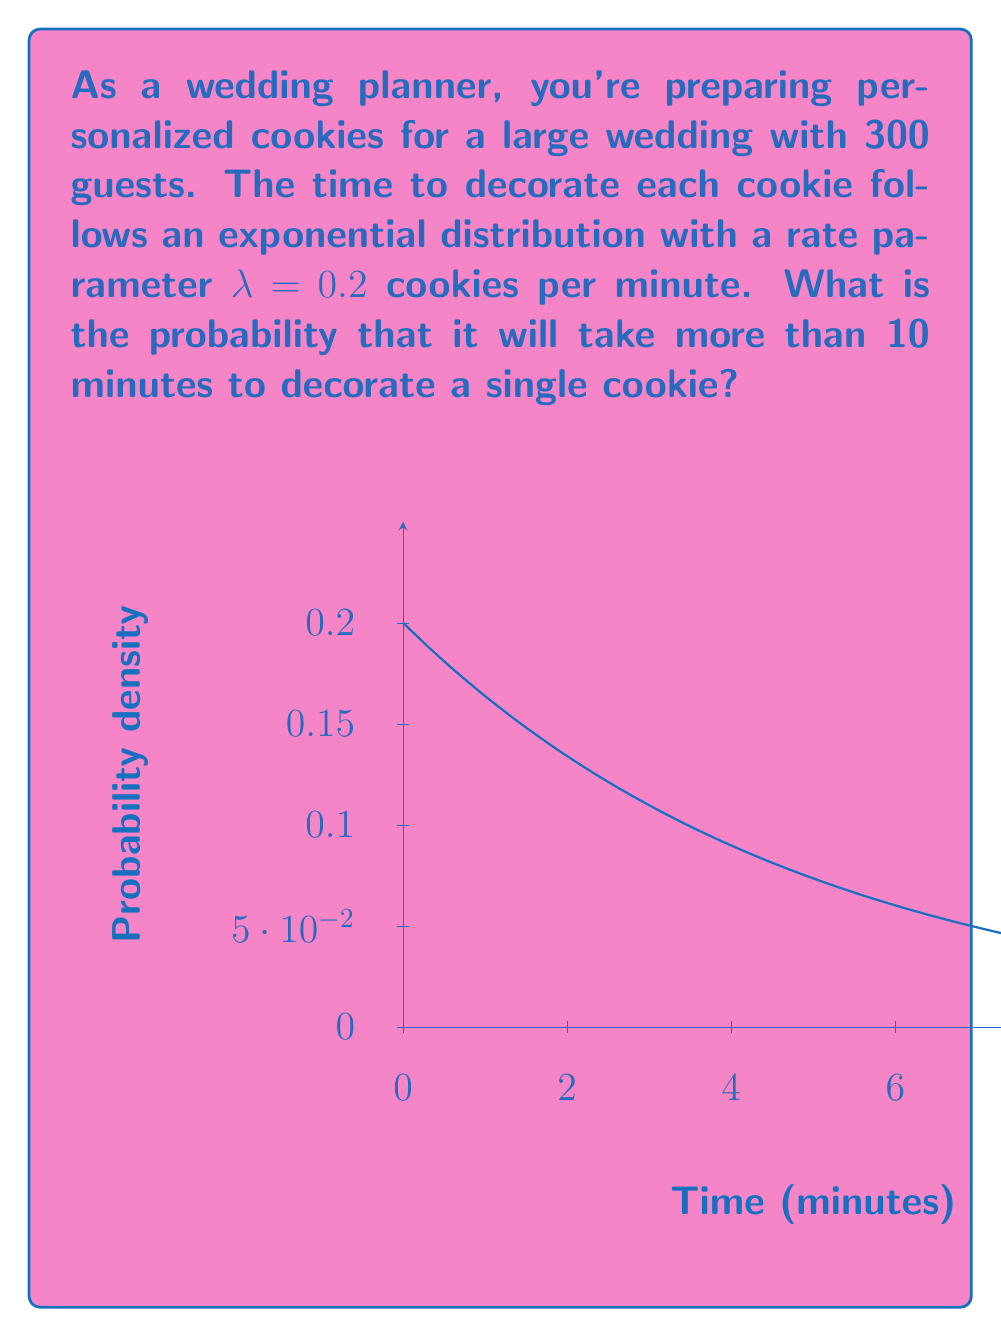Can you answer this question? Let's approach this step-by-step:

1) The exponential distribution is given by the probability density function:
   $$f(x) = λe^{-λx}$$
   where λ is the rate parameter and x is the time.

2) We're asked for the probability that it takes more than 10 minutes to decorate a cookie. This is equivalent to finding P(X > 10), where X is the random variable representing the time to decorate a cookie.

3) For the exponential distribution, the probability of an event taking longer than a certain time t is given by:
   $$P(X > t) = e^{-λt}$$

4) In this case, λ = 0.2 and t = 10. Let's substitute these values:
   $$P(X > 10) = e^{-0.2 * 10}$$

5) Simplify:
   $$P(X > 10) = e^{-2}$$

6) Calculate the result:
   $$P(X > 10) ≈ 0.1353$$

Therefore, the probability that it will take more than 10 minutes to decorate a single cookie is approximately 0.1353 or about 13.53%.
Answer: $e^{-2} ≈ 0.1353$ 